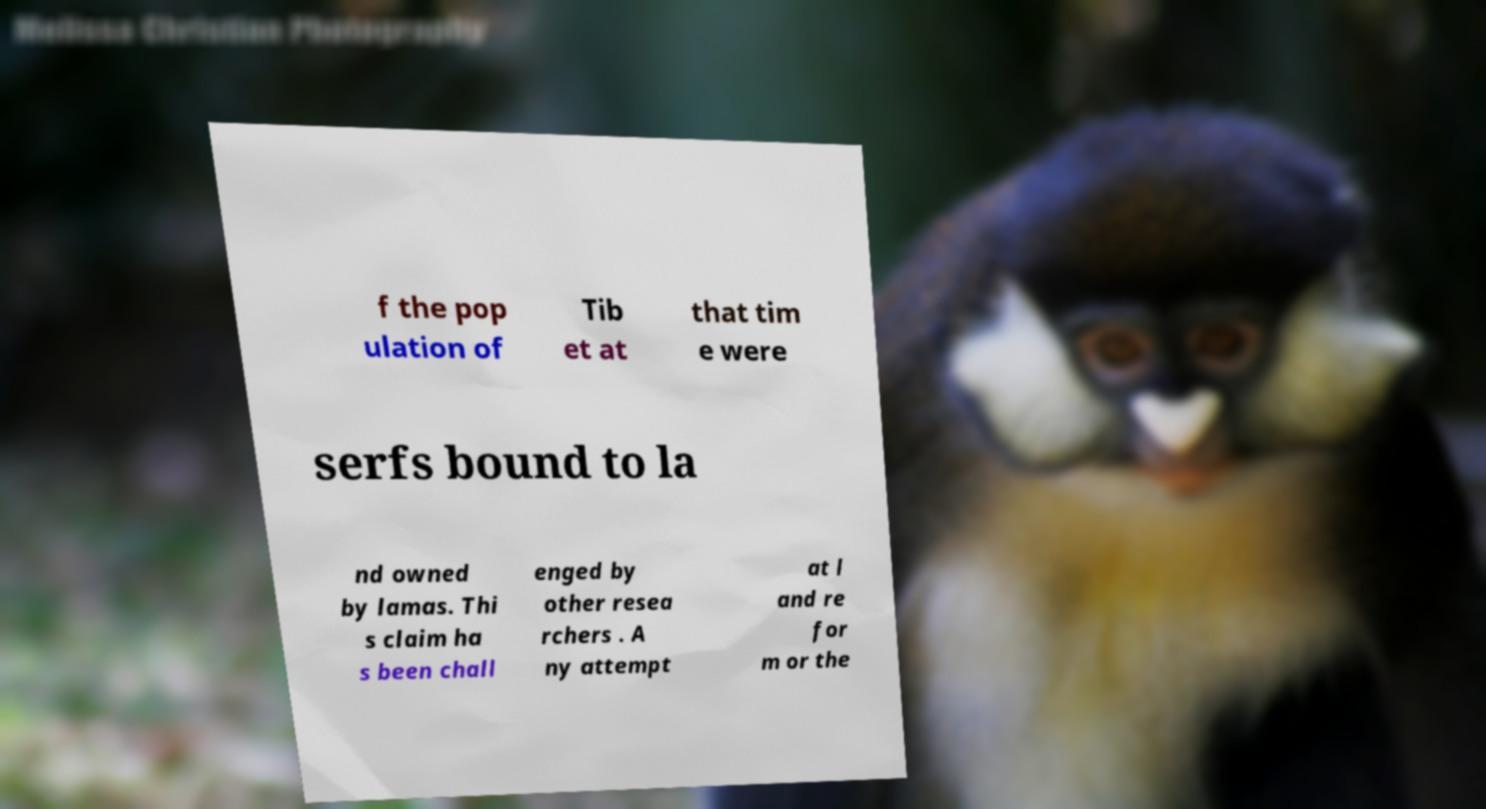I need the written content from this picture converted into text. Can you do that? f the pop ulation of Tib et at that tim e were serfs bound to la nd owned by lamas. Thi s claim ha s been chall enged by other resea rchers . A ny attempt at l and re for m or the 